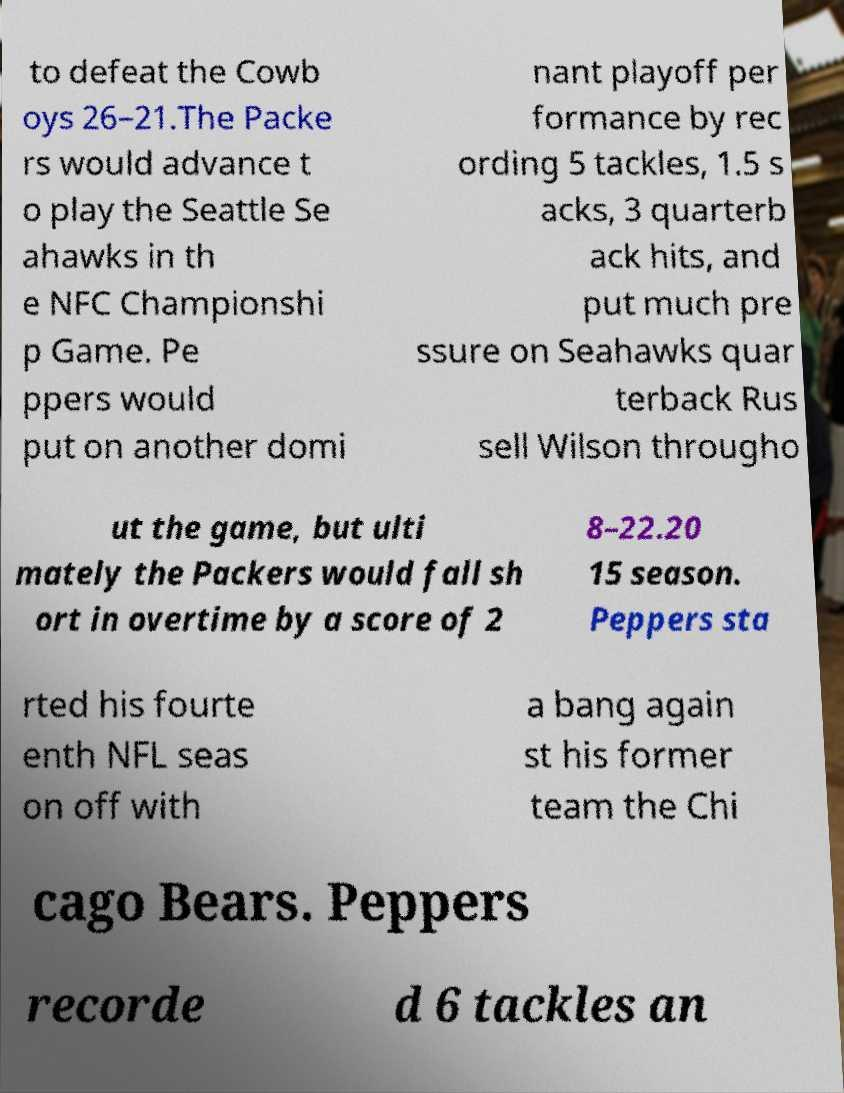Please identify and transcribe the text found in this image. to defeat the Cowb oys 26–21.The Packe rs would advance t o play the Seattle Se ahawks in th e NFC Championshi p Game. Pe ppers would put on another domi nant playoff per formance by rec ording 5 tackles, 1.5 s acks, 3 quarterb ack hits, and put much pre ssure on Seahawks quar terback Rus sell Wilson througho ut the game, but ulti mately the Packers would fall sh ort in overtime by a score of 2 8–22.20 15 season. Peppers sta rted his fourte enth NFL seas on off with a bang again st his former team the Chi cago Bears. Peppers recorde d 6 tackles an 